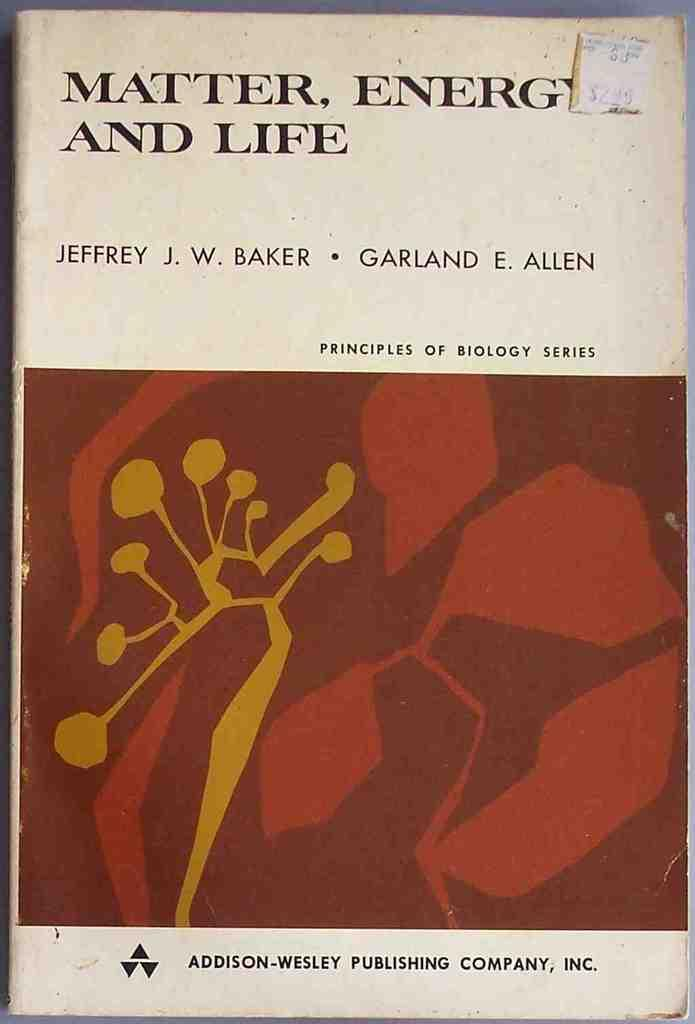<image>
Write a terse but informative summary of the picture. An old book cover titled Matter, Energy and Life by Jeffrey Baker and Garland Allen. 